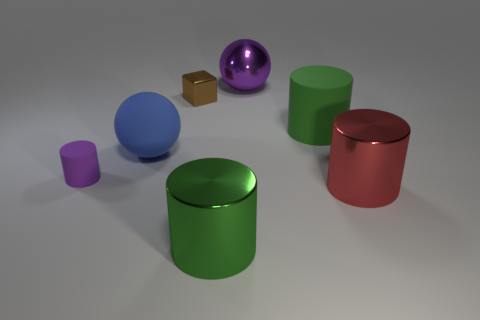Is there anything else that is the same shape as the small brown object?
Make the answer very short. No. There is a green object in front of the large rubber object that is right of the tiny block; how big is it?
Provide a succinct answer. Large. There is another object that is the same shape as the big blue rubber thing; what is its color?
Provide a short and direct response. Purple. Is the size of the green matte object the same as the matte sphere?
Offer a very short reply. Yes. Are there an equal number of purple matte cylinders to the right of the blue rubber sphere and big gray cylinders?
Offer a very short reply. Yes. Are there any spheres that are in front of the thing that is left of the big blue rubber object?
Provide a succinct answer. No. What is the size of the cylinder that is to the left of the large cylinder on the left side of the large purple object behind the big blue thing?
Ensure brevity in your answer.  Small. What material is the small object that is in front of the green thing behind the blue matte sphere made of?
Your answer should be very brief. Rubber. Is there a large purple metal thing of the same shape as the blue object?
Provide a short and direct response. Yes. What is the shape of the green metal thing?
Provide a succinct answer. Cylinder. 